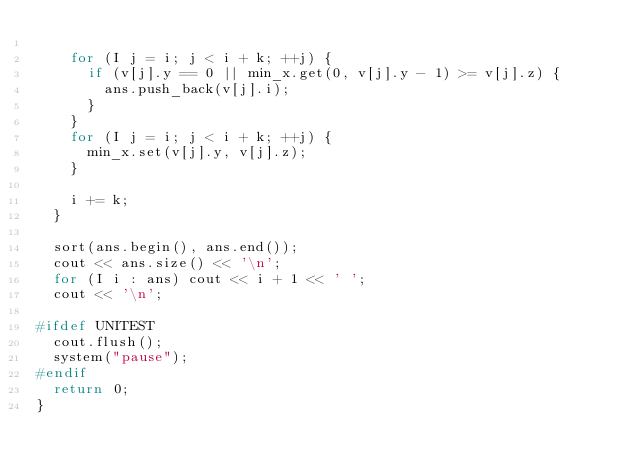<code> <loc_0><loc_0><loc_500><loc_500><_C++_>
    for (I j = i; j < i + k; ++j) {
      if (v[j].y == 0 || min_x.get(0, v[j].y - 1) >= v[j].z) {
        ans.push_back(v[j].i);
      }
    }
    for (I j = i; j < i + k; ++j) {
      min_x.set(v[j].y, v[j].z);
    }

    i += k;
  }

  sort(ans.begin(), ans.end());
  cout << ans.size() << '\n';
  for (I i : ans) cout << i + 1 << ' ';
  cout << '\n';

#ifdef UNITEST
  cout.flush();
  system("pause");
#endif
  return 0;
}
</code> 